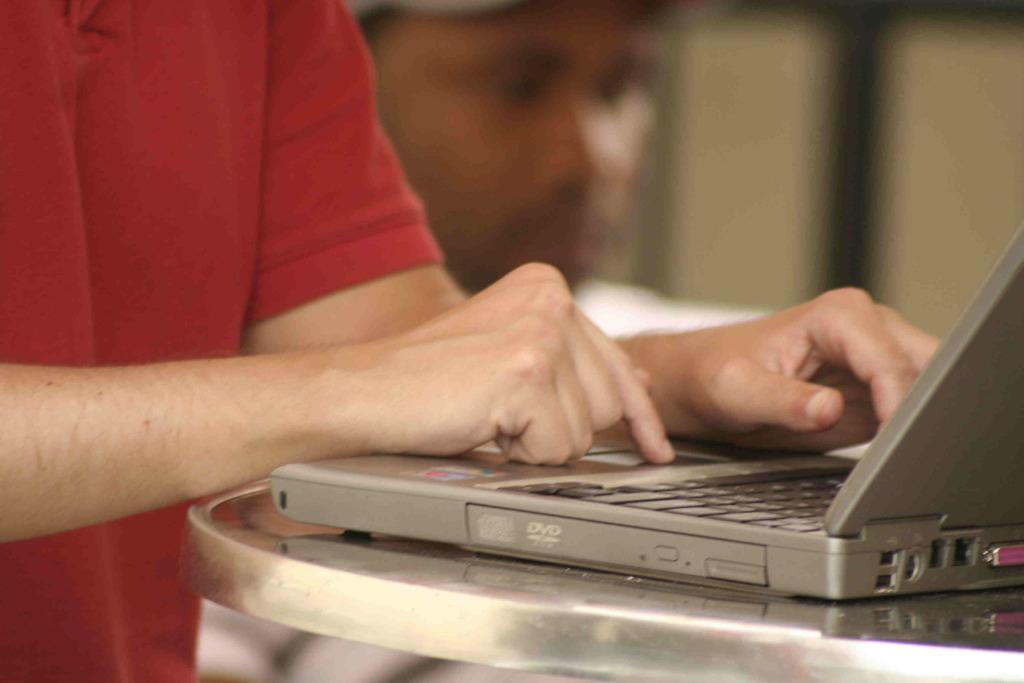<image>
Relay a brief, clear account of the picture shown. A man types on a laptop that says DVD on the side. 